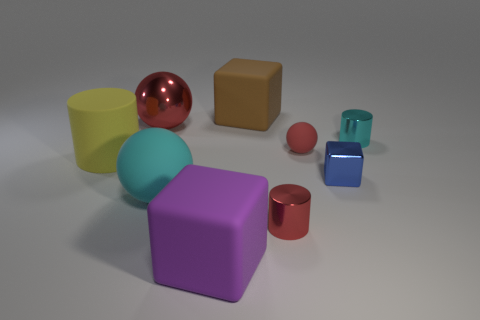How many objects are both behind the big matte cylinder and on the left side of the big red sphere?
Provide a short and direct response. 0. Are the blue block and the big yellow cylinder made of the same material?
Ensure brevity in your answer.  No. The big thing left of the shiny thing left of the cube that is behind the blue thing is what shape?
Give a very brief answer. Cylinder. The block that is in front of the big yellow matte cylinder and behind the purple matte cube is made of what material?
Keep it short and to the point. Metal. There is a matte ball that is to the left of the large cube to the left of the matte block behind the tiny metal block; what is its color?
Ensure brevity in your answer.  Cyan. What number of blue things are tiny matte objects or big matte balls?
Offer a terse response. 0. How many other objects are the same size as the metallic ball?
Offer a very short reply. 4. What number of brown matte cubes are there?
Make the answer very short. 1. Is there any other thing that has the same shape as the large purple thing?
Offer a terse response. Yes. Do the cube behind the tiny blue shiny object and the red sphere in front of the large red shiny ball have the same material?
Offer a terse response. Yes. 